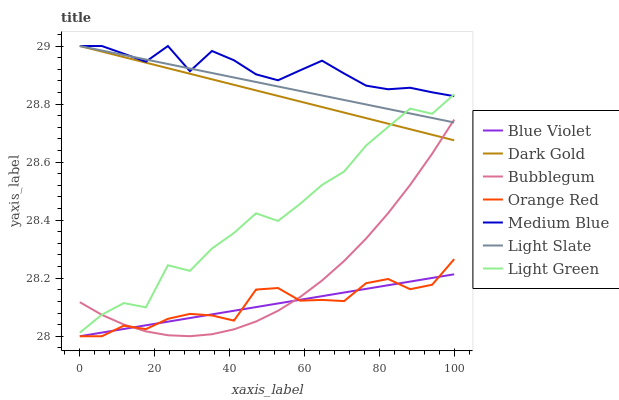Does Blue Violet have the minimum area under the curve?
Answer yes or no. Yes. Does Medium Blue have the maximum area under the curve?
Answer yes or no. Yes. Does Light Slate have the minimum area under the curve?
Answer yes or no. No. Does Light Slate have the maximum area under the curve?
Answer yes or no. No. Is Dark Gold the smoothest?
Answer yes or no. Yes. Is Light Green the roughest?
Answer yes or no. Yes. Is Light Slate the smoothest?
Answer yes or no. No. Is Light Slate the roughest?
Answer yes or no. No. Does Orange Red have the lowest value?
Answer yes or no. Yes. Does Light Slate have the lowest value?
Answer yes or no. No. Does Medium Blue have the highest value?
Answer yes or no. Yes. Does Bubblegum have the highest value?
Answer yes or no. No. Is Blue Violet less than Light Green?
Answer yes or no. Yes. Is Light Slate greater than Orange Red?
Answer yes or no. Yes. Does Blue Violet intersect Orange Red?
Answer yes or no. Yes. Is Blue Violet less than Orange Red?
Answer yes or no. No. Is Blue Violet greater than Orange Red?
Answer yes or no. No. Does Blue Violet intersect Light Green?
Answer yes or no. No. 